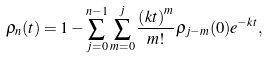<formula> <loc_0><loc_0><loc_500><loc_500>\rho _ { n } ( t ) = 1 - \sum _ { j = 0 } ^ { n - 1 } \sum _ { m = 0 } ^ { j } \frac { \left ( k t \right ) ^ { m } } { m ! } \rho _ { j - m } ( 0 ) e ^ { - k t } ,</formula> 